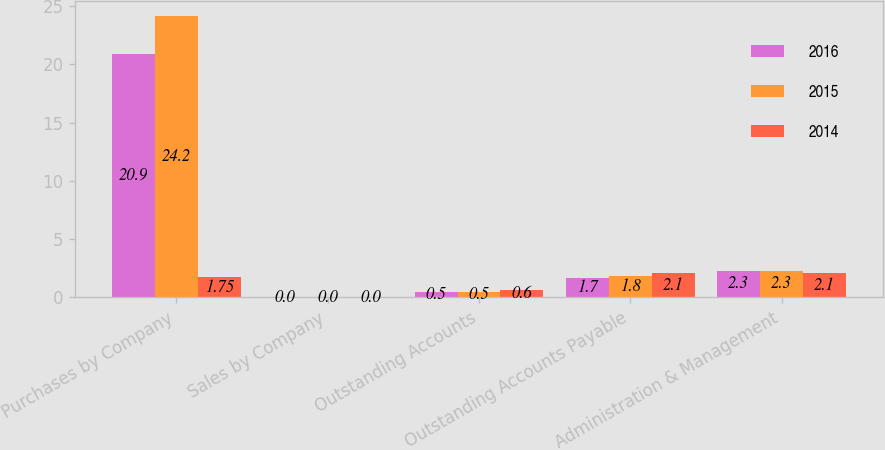Convert chart to OTSL. <chart><loc_0><loc_0><loc_500><loc_500><stacked_bar_chart><ecel><fcel>Purchases by Company<fcel>Sales by Company<fcel>Outstanding Accounts<fcel>Outstanding Accounts Payable<fcel>Administration & Management<nl><fcel>2016<fcel>20.9<fcel>0<fcel>0.5<fcel>1.7<fcel>2.3<nl><fcel>2015<fcel>24.2<fcel>0<fcel>0.5<fcel>1.8<fcel>2.3<nl><fcel>2014<fcel>1.75<fcel>0<fcel>0.6<fcel>2.1<fcel>2.1<nl></chart> 